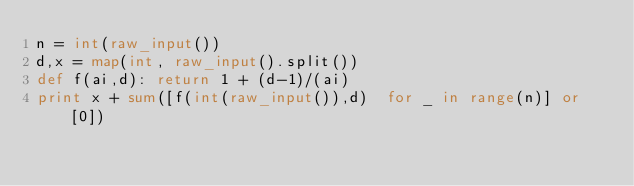Convert code to text. <code><loc_0><loc_0><loc_500><loc_500><_Python_>n = int(raw_input())
d,x = map(int, raw_input().split())
def f(ai,d): return 1 + (d-1)/(ai)
print x + sum([f(int(raw_input()),d)  for _ in range(n)] or [0])</code> 